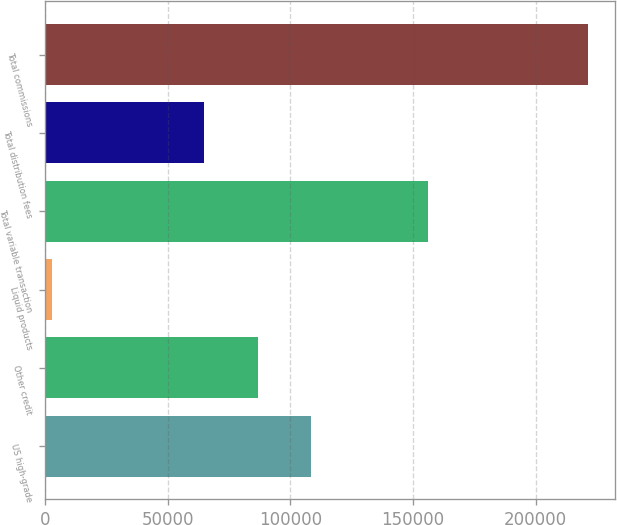Convert chart. <chart><loc_0><loc_0><loc_500><loc_500><bar_chart><fcel>US high-grade<fcel>Other credit<fcel>Liquid products<fcel>Total variable transaction<fcel>Total distribution fees<fcel>Total commissions<nl><fcel>108564<fcel>86733.8<fcel>2840<fcel>156234<fcel>64904<fcel>221138<nl></chart> 